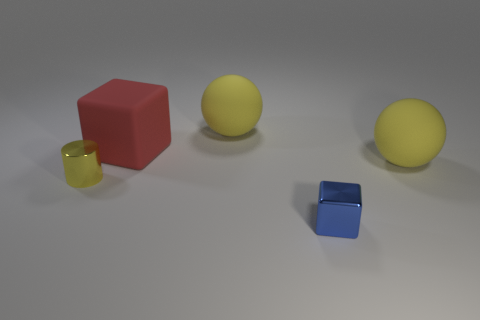Are there any other things that have the same shape as the blue thing?
Give a very brief answer. Yes. Are there fewer red rubber things that are on the left side of the small yellow thing than yellow spheres?
Keep it short and to the point. Yes. There is a small thing in front of the small yellow metallic cylinder; does it have the same color as the tiny metal cylinder?
Make the answer very short. No. What number of matte objects are big cubes or big spheres?
Offer a very short reply. 3. Is there anything else that is the same size as the cylinder?
Your answer should be compact. Yes. There is a small object that is the same material as the small cube; what color is it?
Ensure brevity in your answer.  Yellow. How many cylinders are either large yellow objects or big red rubber objects?
Offer a very short reply. 0. What number of things are large yellow rubber things or yellow spheres right of the small metal cube?
Make the answer very short. 2. Is there a brown matte ball?
Your answer should be compact. No. What number of small cylinders are the same color as the metal cube?
Make the answer very short. 0. 